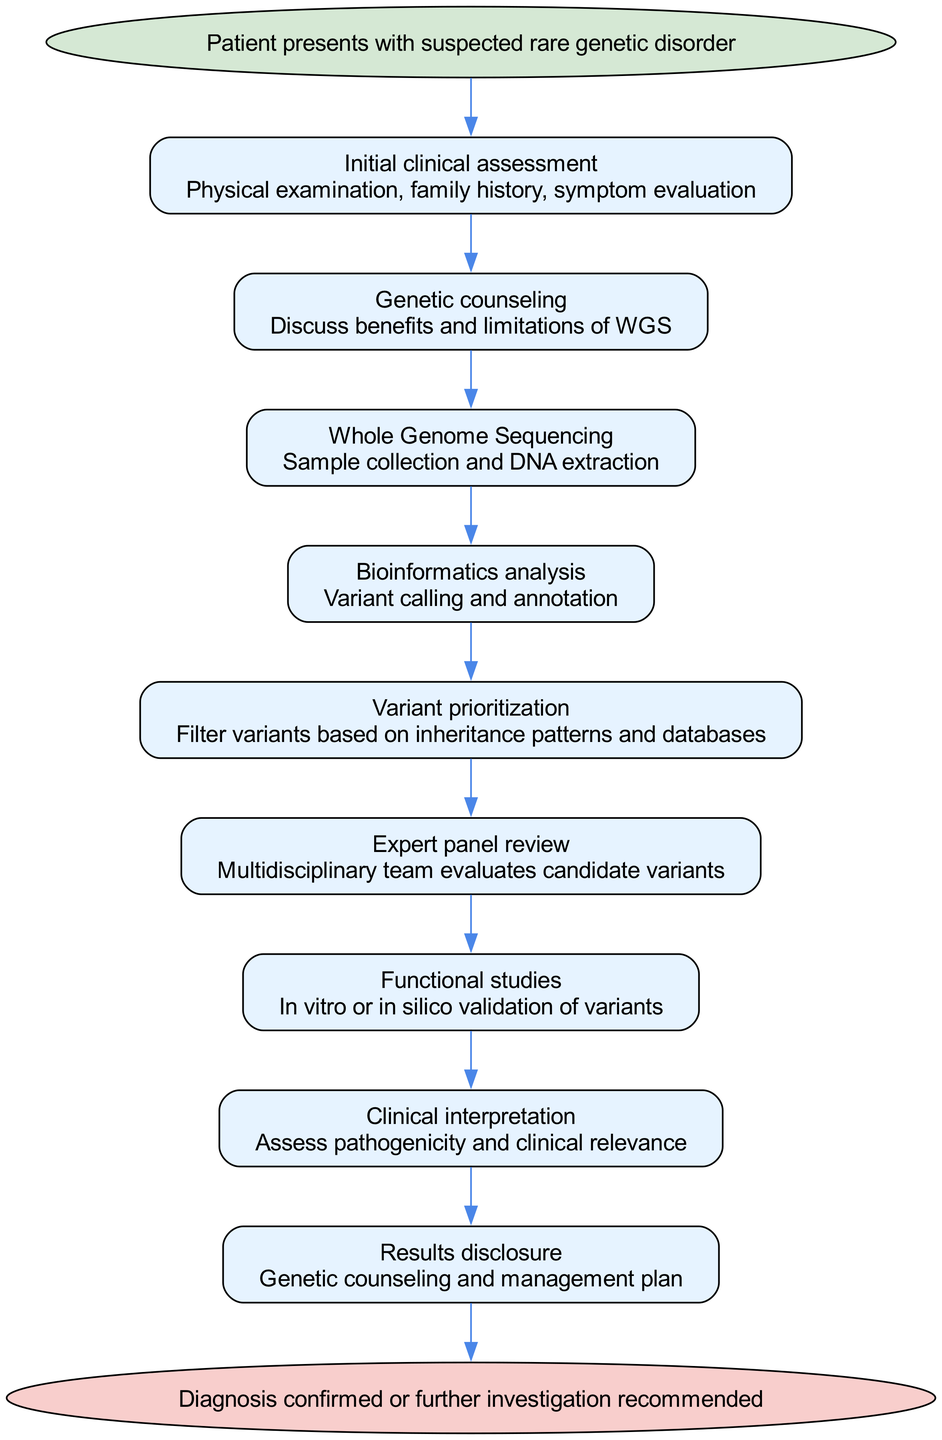What is the starting point of the clinical pathway? The starting point is indicated in the diagram as the first node. It presents the entry into the clinical pathway, where patients begin their journey. According to the diagram, the starting point is "Patient presents with suspected rare genetic disorder."
Answer: Patient presents with suspected rare genetic disorder How many steps are there in the diagnostic pathway? The total number of steps can be counted by reviewing the nodes after the starting point until reaching the end point. There are eight steps before concluding with the end point.
Answer: Eight What step directly follows "Genetic counseling"? To determine this, one can look at the sequence of nodes. The step "Whole Genome Sequencing" comes right after "Genetic counseling" in the pathway.
Answer: Whole Genome Sequencing What is the end point of the clinical pathway? By looking at the final node in the diagram, we can find the end point. This endpoint summarizes the outcome of the clinical pathway. The end point is "Diagnosis confirmed or further investigation recommended."
Answer: Diagnosis confirmed or further investigation recommended Which step involves the evaluation of candidate variants? The step that deals with the evaluation of variants is "Expert panel review." This step logically follows the prior analysis steps, where variants have already been prioritized.
Answer: Expert panel review What is the main purpose of bioinformatics analysis in the pathway? To answer this, we can refer to the details associated with the "Bioinformatics analysis" step in the diagram. This step is focused on "Variant calling and annotation," which highlights its main function.
Answer: Variant calling and annotation How does the patient progress from "Initial clinical assessment" to "Results disclosure"? This progression involves a series of connected steps. After the "Initial clinical assessment," the pathway goes to "Genetic counseling," then follows through "Whole Genome Sequencing," continues to "Bioinformatics analysis," and goes through several more steps until reaching "Results disclosure." Each step logically builds on the last one.
Answer: Through subsequent evaluation and analysis steps What is the significance of functional studies in this pathway? The "Functional studies" step is crucial as it involves the in vitro or in silico validation of variants. This indicates its role in testing the viability of the identified genetic variants.
Answer: In vitro or in silico validation of variants 